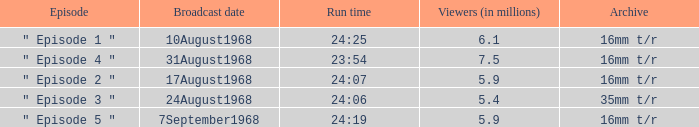How many episodes in history have a running time of 24:06? 1.0. 